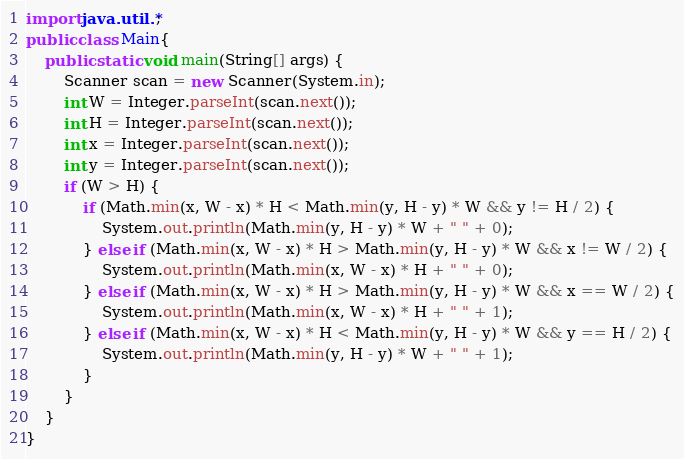Convert code to text. <code><loc_0><loc_0><loc_500><loc_500><_Java_>import java.util.*;
public class Main{
    public static void main(String[] args) {
        Scanner scan = new Scanner(System.in);
        int W = Integer.parseInt(scan.next());
        int H = Integer.parseInt(scan.next());
        int x = Integer.parseInt(scan.next());
        int y = Integer.parseInt(scan.next());
        if (W > H) {
            if (Math.min(x, W - x) * H < Math.min(y, H - y) * W && y != H / 2) {
                System.out.println(Math.min(y, H - y) * W + " " + 0);
            } else if (Math.min(x, W - x) * H > Math.min(y, H - y) * W && x != W / 2) {
                System.out.println(Math.min(x, W - x) * H + " " + 0);
            } else if (Math.min(x, W - x) * H > Math.min(y, H - y) * W && x == W / 2) {
                System.out.println(Math.min(x, W - x) * H + " " + 1);
            } else if (Math.min(x, W - x) * H < Math.min(y, H - y) * W && y == H / 2) {
                System.out.println(Math.min(y, H - y) * W + " " + 1);
            }
        }
    }
}
</code> 